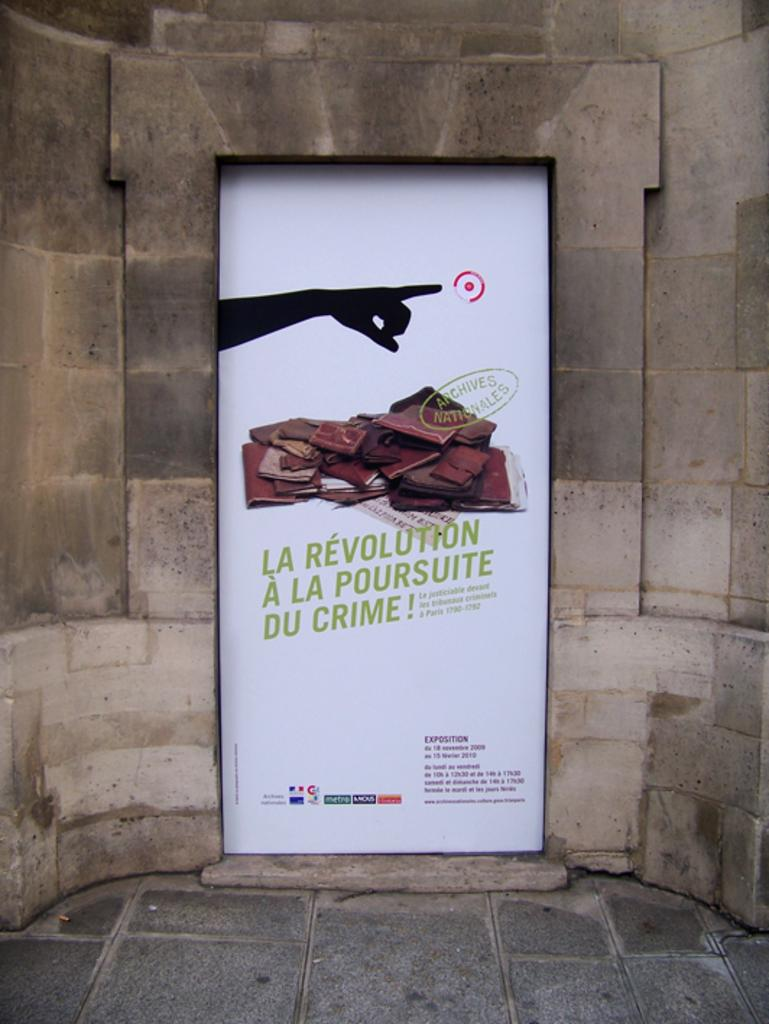<image>
Give a short and clear explanation of the subsequent image. Advertisement with a finger pointing and says "La Revolution A La Poursuite Du Crime!". 